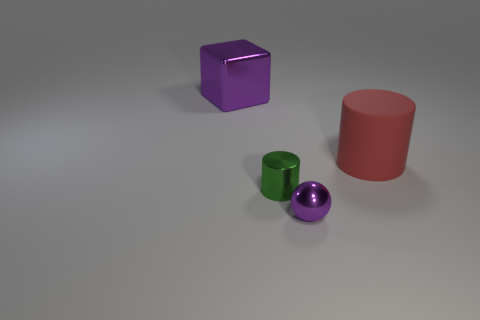There is a big metal block; are there any large purple metal cubes to the right of it?
Provide a short and direct response. No. What number of other things are there of the same shape as the green shiny object?
Ensure brevity in your answer.  1. What color is the sphere that is the same size as the metal cylinder?
Keep it short and to the point. Purple. Is the number of big purple metal blocks right of the small shiny sphere less than the number of large purple objects that are behind the tiny green thing?
Your answer should be compact. Yes. How many objects are behind the purple metal thing on the right side of the thing that is behind the matte object?
Make the answer very short. 3. There is a green thing that is the same shape as the red matte thing; what is its size?
Make the answer very short. Small. Is there anything else that has the same size as the purple cube?
Your answer should be compact. Yes. Are there fewer small purple metallic balls that are behind the big block than tiny brown cylinders?
Keep it short and to the point. No. Is the tiny purple metallic object the same shape as the tiny green metallic thing?
Provide a succinct answer. No. What color is the large object that is the same shape as the tiny green thing?
Provide a short and direct response. Red. 